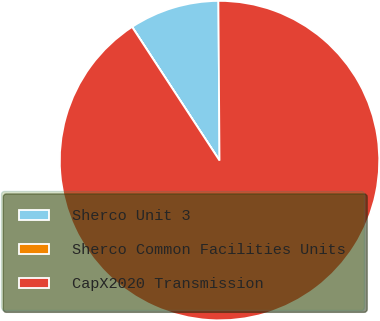Convert chart. <chart><loc_0><loc_0><loc_500><loc_500><pie_chart><fcel>Sherco Unit 3<fcel>Sherco Common Facilities Units<fcel>CapX2020 Transmission<nl><fcel>9.1%<fcel>0.01%<fcel>90.89%<nl></chart> 